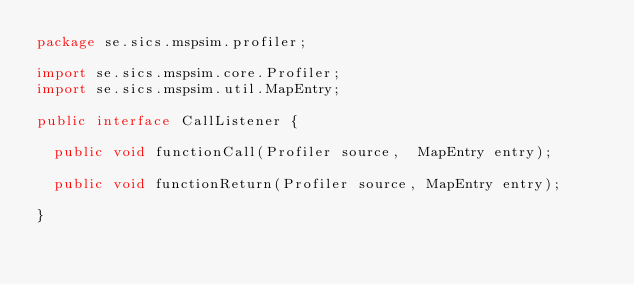Convert code to text. <code><loc_0><loc_0><loc_500><loc_500><_Java_>package se.sics.mspsim.profiler;

import se.sics.mspsim.core.Profiler;
import se.sics.mspsim.util.MapEntry;

public interface CallListener {

  public void functionCall(Profiler source,  MapEntry entry);

  public void functionReturn(Profiler source, MapEntry entry);

}
</code> 